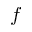Convert formula to latex. <formula><loc_0><loc_0><loc_500><loc_500>f</formula> 